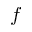Convert formula to latex. <formula><loc_0><loc_0><loc_500><loc_500>f</formula> 